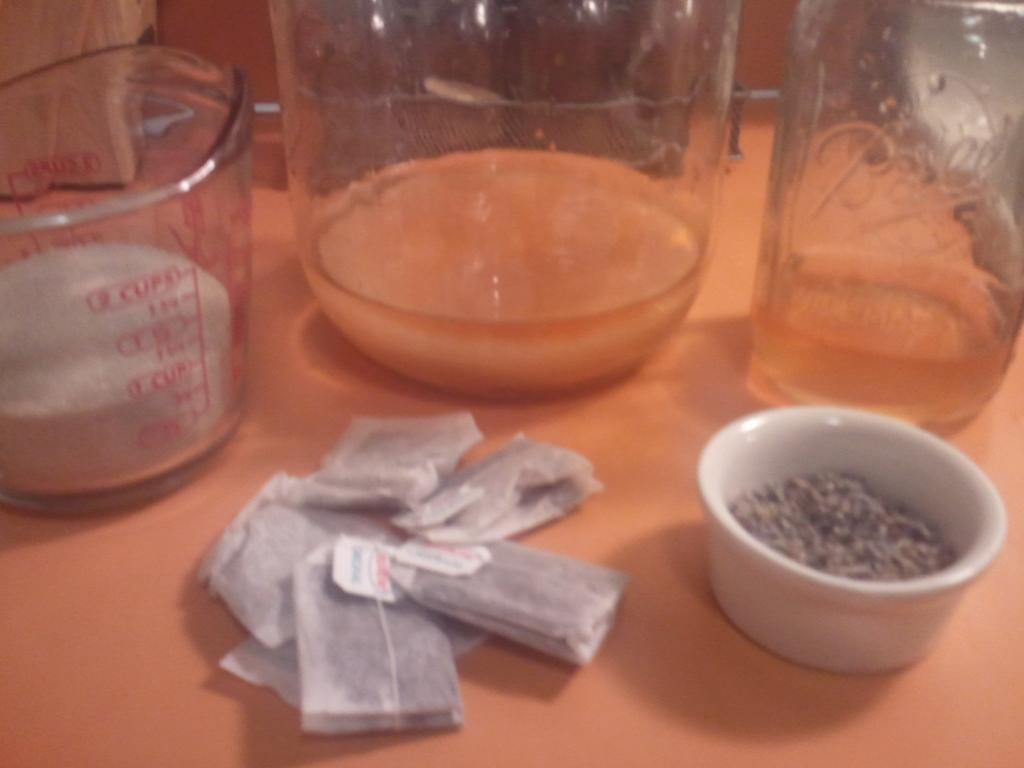Provide a one-sentence caption for the provided image. Glass beakers on a table with one holding something at 0 cups. 